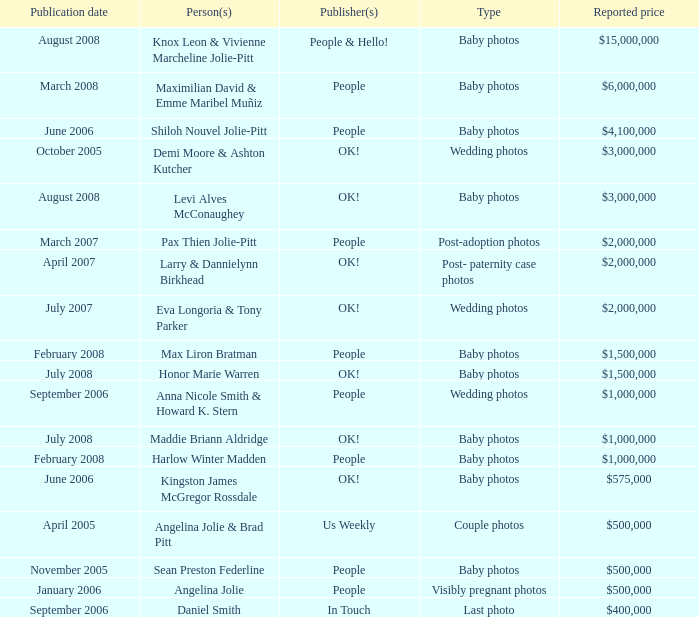What type of photos of Angelina Jolie cost $500,000? Visibly pregnant photos. 